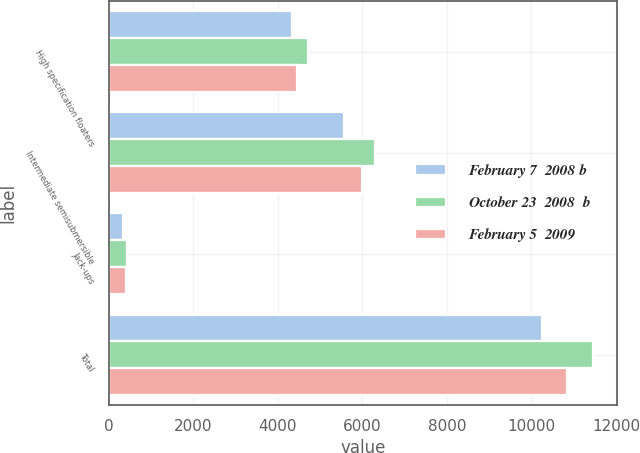Convert chart. <chart><loc_0><loc_0><loc_500><loc_500><stacked_bar_chart><ecel><fcel>High specification floaters<fcel>Intermediate semisubmersible<fcel>Jack-ups<fcel>Total<nl><fcel>February 7  2008 b<fcel>4346<fcel>5567<fcel>346<fcel>10259<nl><fcel>October 23  2008  b<fcel>4720<fcel>6302<fcel>428<fcel>11450<nl><fcel>February 5  2009<fcel>4448<fcel>5985<fcel>421<fcel>10854<nl></chart> 